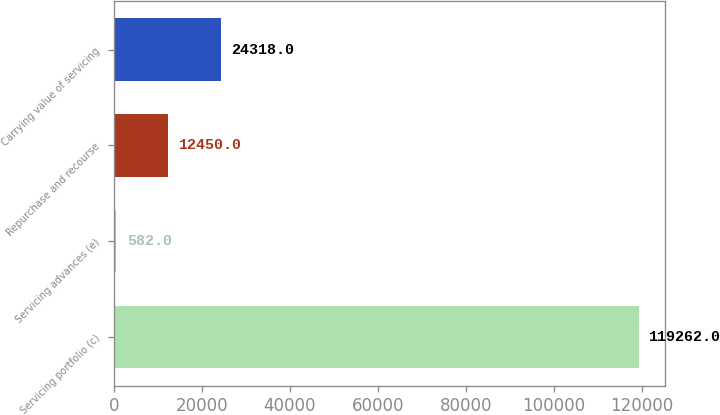<chart> <loc_0><loc_0><loc_500><loc_500><bar_chart><fcel>Servicing portfolio (c)<fcel>Servicing advances (e)<fcel>Repurchase and recourse<fcel>Carrying value of servicing<nl><fcel>119262<fcel>582<fcel>12450<fcel>24318<nl></chart> 